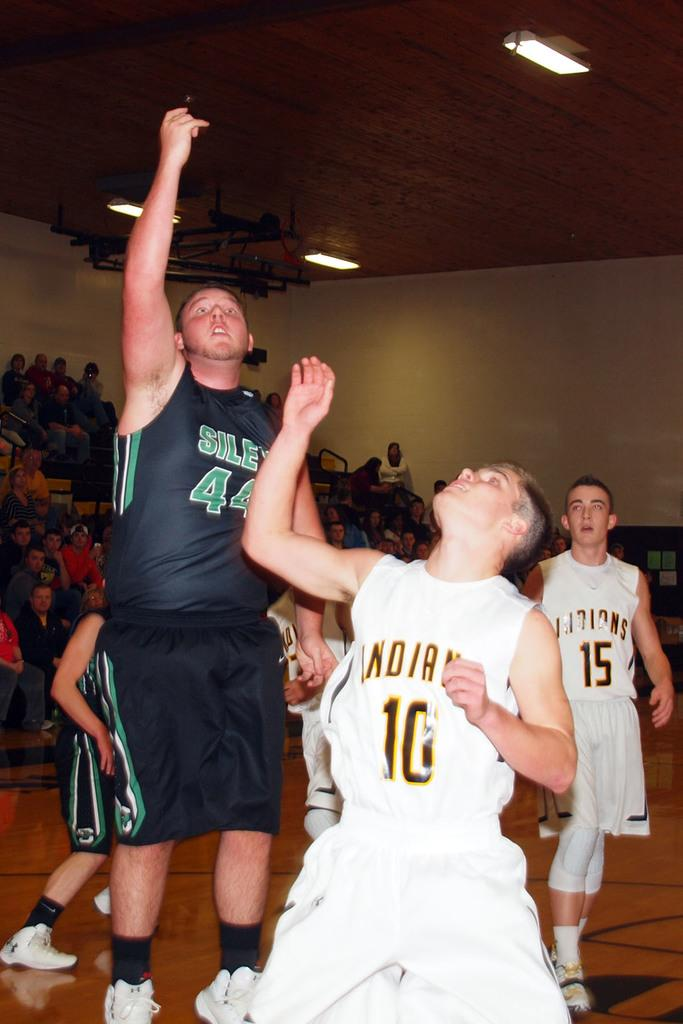<image>
Provide a brief description of the given image. The Indians may or may not win their basketball game. 